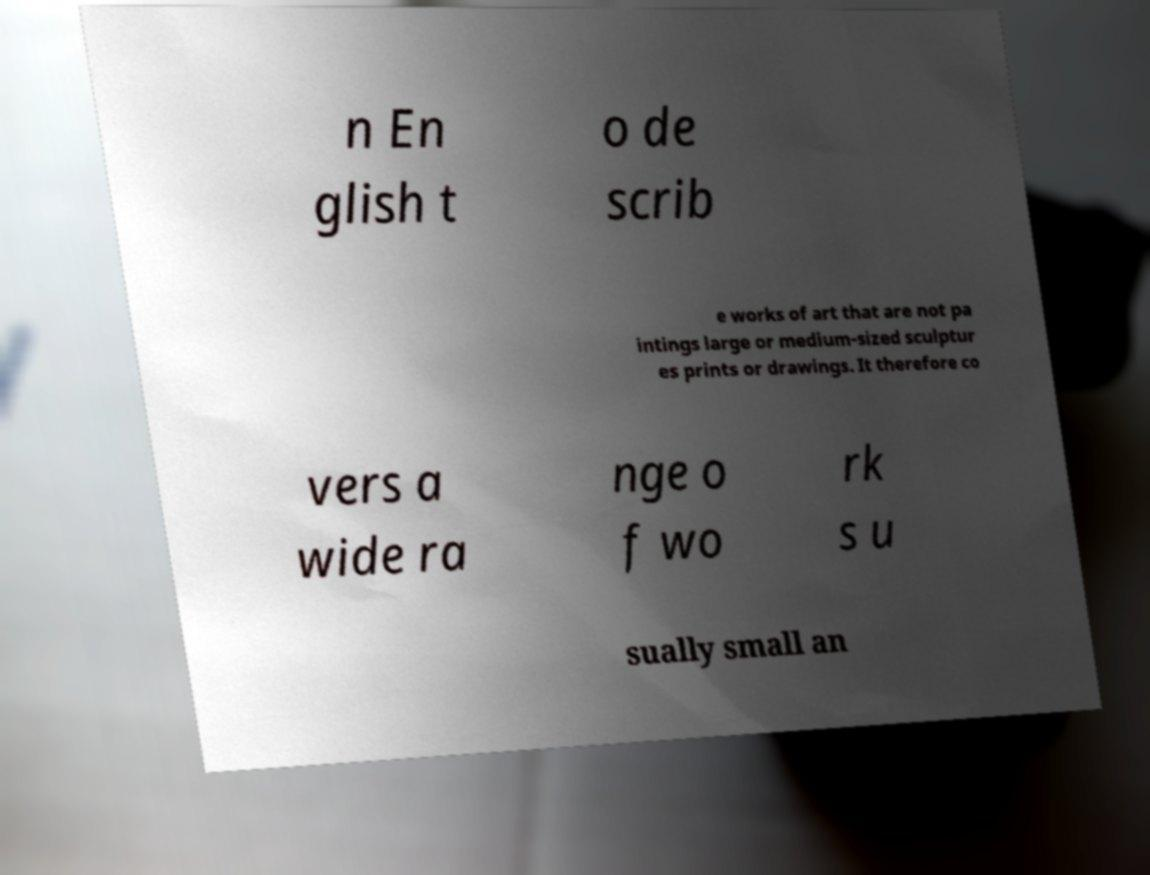Can you read and provide the text displayed in the image?This photo seems to have some interesting text. Can you extract and type it out for me? n En glish t o de scrib e works of art that are not pa intings large or medium-sized sculptur es prints or drawings. It therefore co vers a wide ra nge o f wo rk s u sually small an 